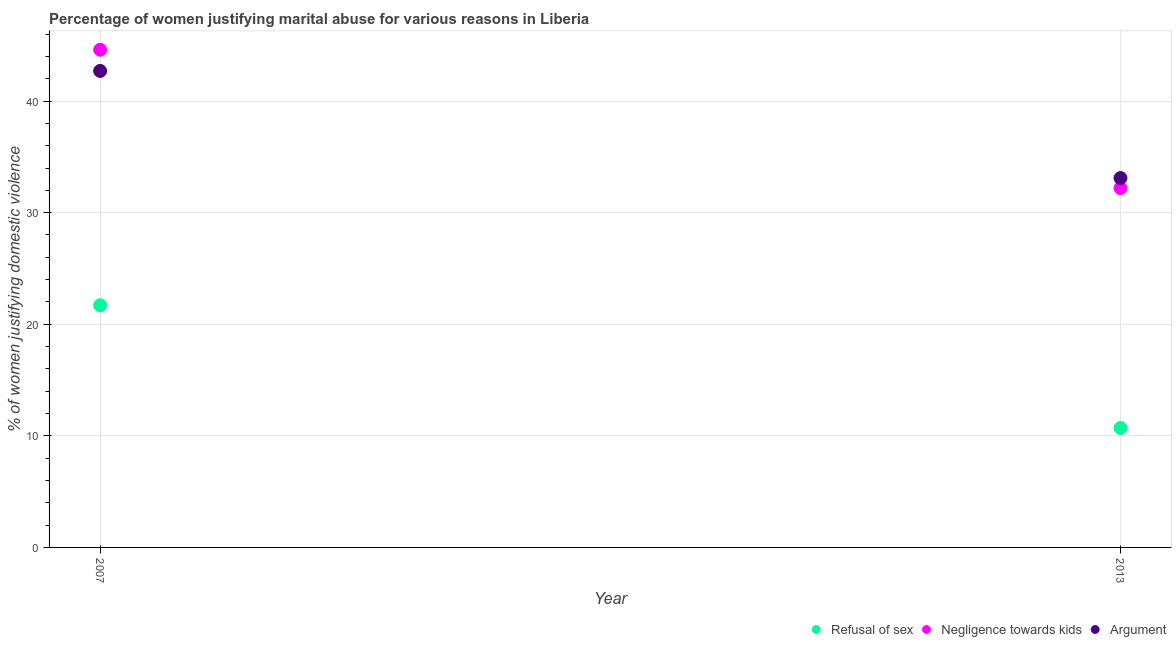How many different coloured dotlines are there?
Make the answer very short. 3. Is the number of dotlines equal to the number of legend labels?
Your response must be concise. Yes. Across all years, what is the maximum percentage of women justifying domestic violence due to arguments?
Ensure brevity in your answer.  42.7. Across all years, what is the minimum percentage of women justifying domestic violence due to arguments?
Your answer should be compact. 33.1. What is the total percentage of women justifying domestic violence due to negligence towards kids in the graph?
Your response must be concise. 76.8. What is the difference between the percentage of women justifying domestic violence due to arguments in 2007 and that in 2013?
Make the answer very short. 9.6. What is the average percentage of women justifying domestic violence due to refusal of sex per year?
Your response must be concise. 16.2. In the year 2013, what is the difference between the percentage of women justifying domestic violence due to negligence towards kids and percentage of women justifying domestic violence due to arguments?
Your answer should be compact. -0.9. In how many years, is the percentage of women justifying domestic violence due to refusal of sex greater than 4 %?
Offer a very short reply. 2. What is the ratio of the percentage of women justifying domestic violence due to arguments in 2007 to that in 2013?
Keep it short and to the point. 1.29. Is the percentage of women justifying domestic violence due to arguments in 2007 less than that in 2013?
Ensure brevity in your answer.  No. Is it the case that in every year, the sum of the percentage of women justifying domestic violence due to refusal of sex and percentage of women justifying domestic violence due to negligence towards kids is greater than the percentage of women justifying domestic violence due to arguments?
Offer a very short reply. Yes. Does the percentage of women justifying domestic violence due to negligence towards kids monotonically increase over the years?
Make the answer very short. No. Is the percentage of women justifying domestic violence due to refusal of sex strictly greater than the percentage of women justifying domestic violence due to arguments over the years?
Keep it short and to the point. No. How many dotlines are there?
Provide a short and direct response. 3. What is the difference between two consecutive major ticks on the Y-axis?
Provide a short and direct response. 10. How many legend labels are there?
Keep it short and to the point. 3. How are the legend labels stacked?
Your answer should be very brief. Horizontal. What is the title of the graph?
Your answer should be very brief. Percentage of women justifying marital abuse for various reasons in Liberia. Does "Total employers" appear as one of the legend labels in the graph?
Offer a terse response. No. What is the label or title of the X-axis?
Your response must be concise. Year. What is the label or title of the Y-axis?
Offer a terse response. % of women justifying domestic violence. What is the % of women justifying domestic violence of Refusal of sex in 2007?
Offer a very short reply. 21.7. What is the % of women justifying domestic violence in Negligence towards kids in 2007?
Your response must be concise. 44.6. What is the % of women justifying domestic violence of Argument in 2007?
Provide a succinct answer. 42.7. What is the % of women justifying domestic violence in Refusal of sex in 2013?
Provide a succinct answer. 10.7. What is the % of women justifying domestic violence in Negligence towards kids in 2013?
Offer a very short reply. 32.2. What is the % of women justifying domestic violence of Argument in 2013?
Your answer should be compact. 33.1. Across all years, what is the maximum % of women justifying domestic violence in Refusal of sex?
Offer a terse response. 21.7. Across all years, what is the maximum % of women justifying domestic violence in Negligence towards kids?
Provide a succinct answer. 44.6. Across all years, what is the maximum % of women justifying domestic violence in Argument?
Offer a terse response. 42.7. Across all years, what is the minimum % of women justifying domestic violence in Refusal of sex?
Give a very brief answer. 10.7. Across all years, what is the minimum % of women justifying domestic violence in Negligence towards kids?
Give a very brief answer. 32.2. Across all years, what is the minimum % of women justifying domestic violence of Argument?
Give a very brief answer. 33.1. What is the total % of women justifying domestic violence in Refusal of sex in the graph?
Give a very brief answer. 32.4. What is the total % of women justifying domestic violence of Negligence towards kids in the graph?
Ensure brevity in your answer.  76.8. What is the total % of women justifying domestic violence of Argument in the graph?
Offer a terse response. 75.8. What is the difference between the % of women justifying domestic violence of Refusal of sex in 2007 and that in 2013?
Make the answer very short. 11. What is the difference between the % of women justifying domestic violence of Argument in 2007 and that in 2013?
Offer a terse response. 9.6. What is the difference between the % of women justifying domestic violence in Refusal of sex in 2007 and the % of women justifying domestic violence in Argument in 2013?
Provide a succinct answer. -11.4. What is the difference between the % of women justifying domestic violence in Negligence towards kids in 2007 and the % of women justifying domestic violence in Argument in 2013?
Make the answer very short. 11.5. What is the average % of women justifying domestic violence of Negligence towards kids per year?
Provide a short and direct response. 38.4. What is the average % of women justifying domestic violence of Argument per year?
Give a very brief answer. 37.9. In the year 2007, what is the difference between the % of women justifying domestic violence in Refusal of sex and % of women justifying domestic violence in Negligence towards kids?
Your answer should be compact. -22.9. In the year 2007, what is the difference between the % of women justifying domestic violence of Refusal of sex and % of women justifying domestic violence of Argument?
Offer a terse response. -21. In the year 2007, what is the difference between the % of women justifying domestic violence of Negligence towards kids and % of women justifying domestic violence of Argument?
Your response must be concise. 1.9. In the year 2013, what is the difference between the % of women justifying domestic violence of Refusal of sex and % of women justifying domestic violence of Negligence towards kids?
Give a very brief answer. -21.5. In the year 2013, what is the difference between the % of women justifying domestic violence in Refusal of sex and % of women justifying domestic violence in Argument?
Offer a terse response. -22.4. What is the ratio of the % of women justifying domestic violence in Refusal of sex in 2007 to that in 2013?
Offer a terse response. 2.03. What is the ratio of the % of women justifying domestic violence in Negligence towards kids in 2007 to that in 2013?
Keep it short and to the point. 1.39. What is the ratio of the % of women justifying domestic violence in Argument in 2007 to that in 2013?
Offer a very short reply. 1.29. What is the difference between the highest and the second highest % of women justifying domestic violence in Refusal of sex?
Ensure brevity in your answer.  11. What is the difference between the highest and the second highest % of women justifying domestic violence of Negligence towards kids?
Keep it short and to the point. 12.4. What is the difference between the highest and the lowest % of women justifying domestic violence of Refusal of sex?
Ensure brevity in your answer.  11. What is the difference between the highest and the lowest % of women justifying domestic violence of Argument?
Ensure brevity in your answer.  9.6. 